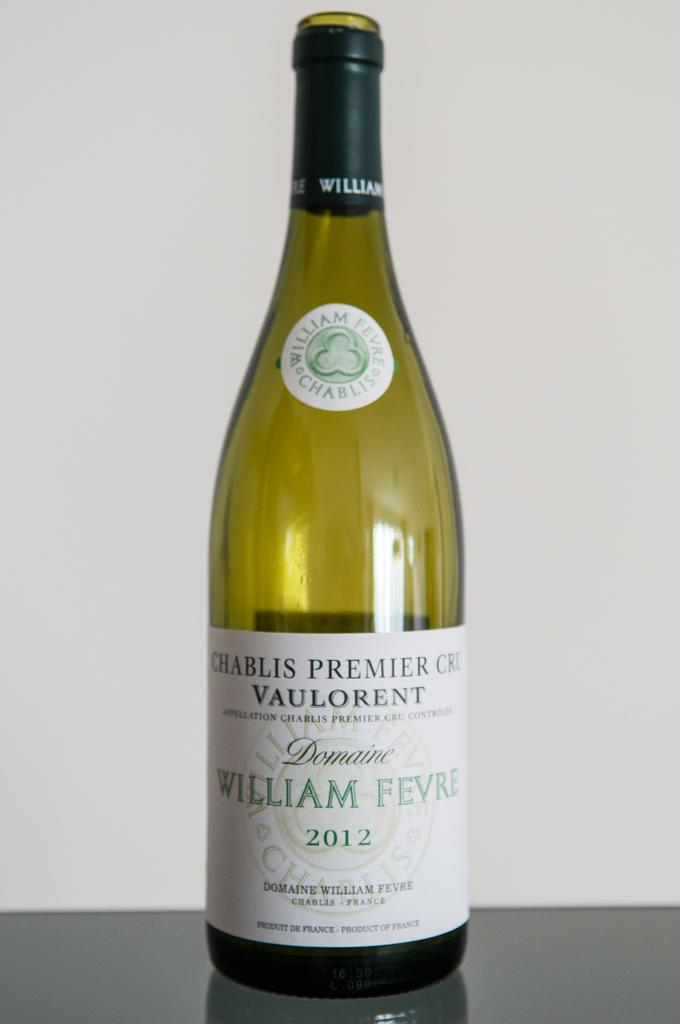<image>
Present a compact description of the photo's key features. A bottle of French Chablis from 2012 sitting by itself on a glass surface. 